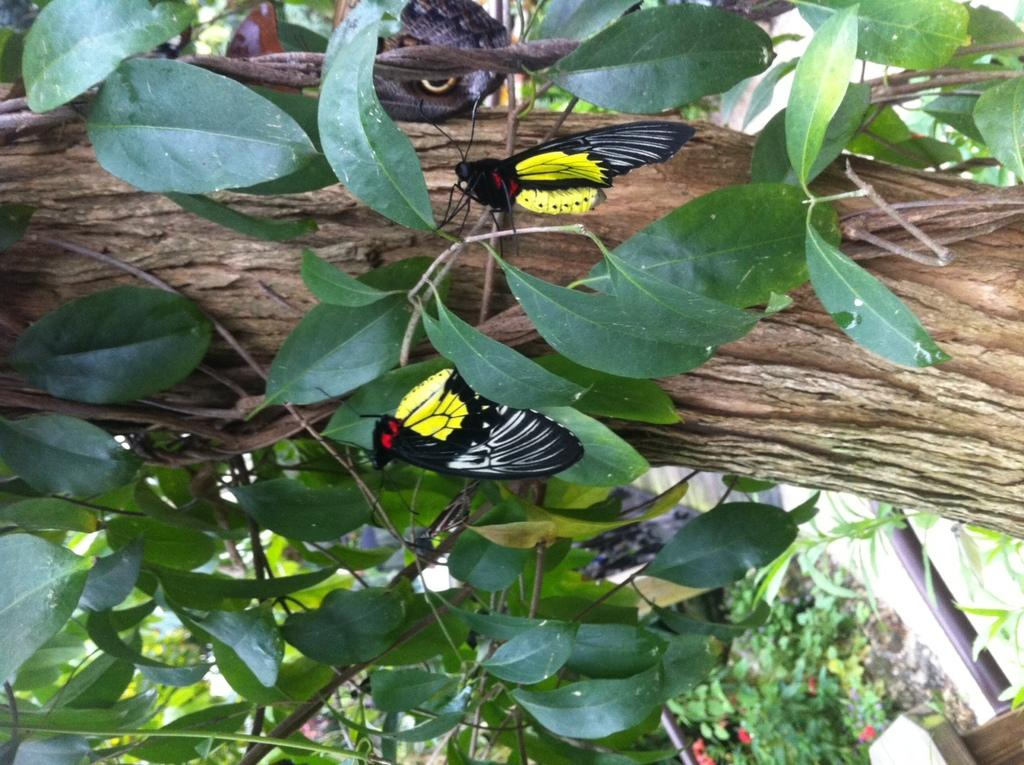What type of plant is growing on the tree trunk in the image? There is a creeper plant on the tree trunk in the image. What insects can be seen on the leaves in the image? Butterflies are present on the leaves in the image. What type of plants can be seen in the background of the image? There are plants with flowers in the background of the image. What structure is visible in the background of the image? There is an iron rod attached to a pillar in the background of the image. Can you tell me how deep the ocean is in the image? There is no ocean present in the image; it features a tree with a creeper plant and butterflies on the leaves. Is there a volcano visible in the image? No, there is no volcano present in the image. 